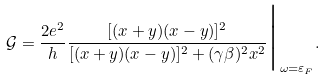Convert formula to latex. <formula><loc_0><loc_0><loc_500><loc_500>\mathcal { G } = \frac { 2 e ^ { 2 } } { h } \frac { [ ( x + y ) ( x - y ) ] ^ { 2 } } { [ ( x + y ) ( x - y ) ] ^ { 2 } + ( \gamma \beta ) ^ { 2 } x ^ { 2 } } \Big | _ { \omega = \varepsilon _ { F } } .</formula> 